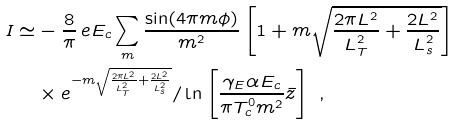Convert formula to latex. <formula><loc_0><loc_0><loc_500><loc_500>I \simeq & - \frac { 8 } { \pi } \, e E _ { c } \sum _ { m } \frac { \sin ( 4 \pi m \phi ) } { m ^ { 2 } } \left [ 1 + m \sqrt { \frac { 2 \pi L ^ { 2 } } { L _ { T } ^ { 2 } } + \frac { 2 L ^ { 2 } } { L _ { s } ^ { 2 } } } \right ] \\ & \times e ^ { - m \sqrt { \frac { 2 \pi L ^ { 2 } } { L _ { T } ^ { 2 } } + \frac { 2 L ^ { 2 } } { L _ { s } ^ { 2 } } } } / \ln \left [ \frac { \gamma _ { E } \alpha E _ { c } } { \pi T _ { c } ^ { 0 } m ^ { 2 } } \bar { z } \right ] \ ,</formula> 